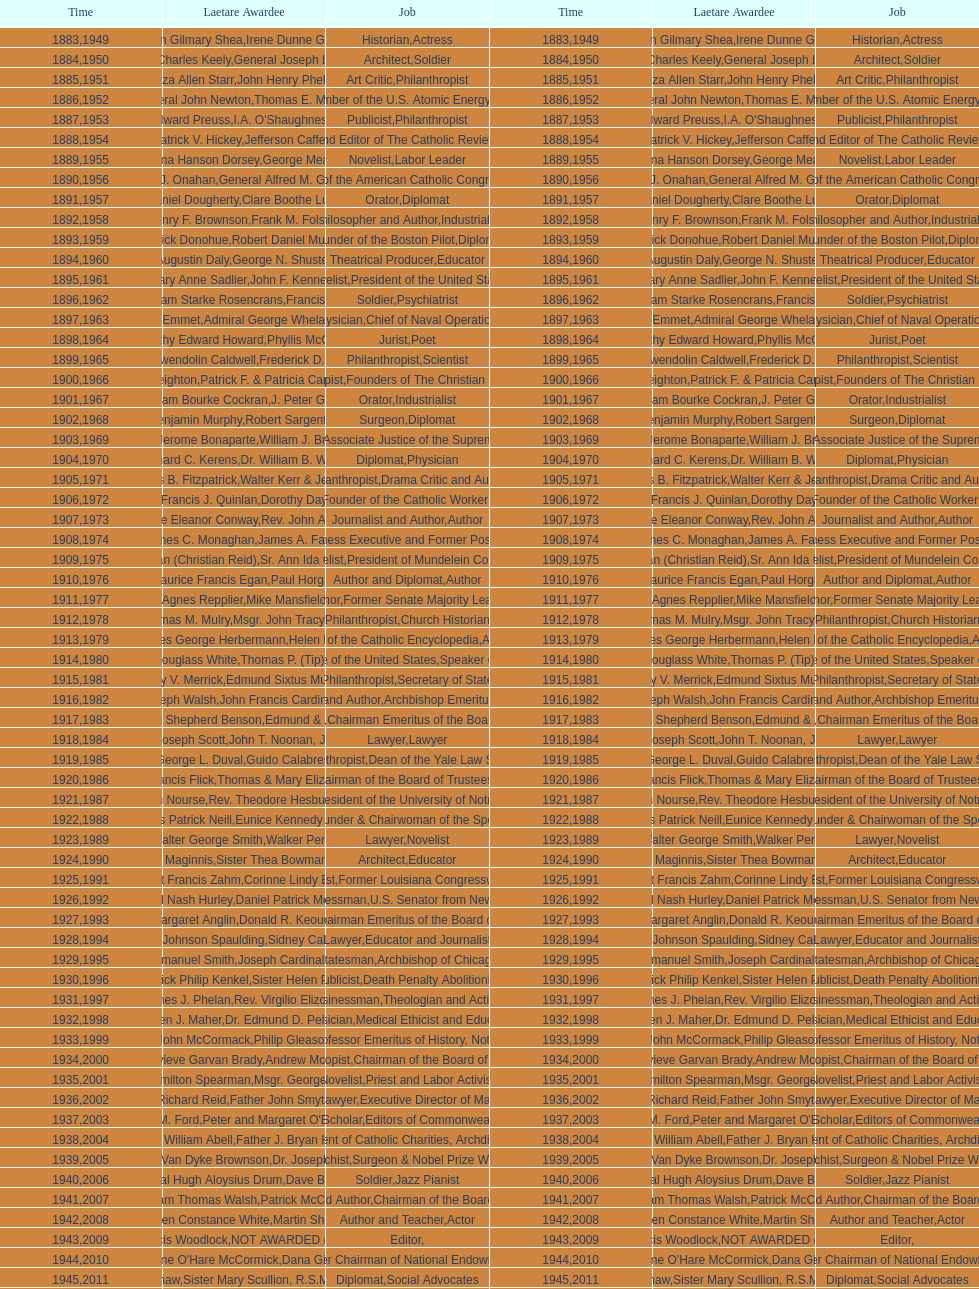What is the name of the laetare medalist listed before edward preuss? General John Newton. 